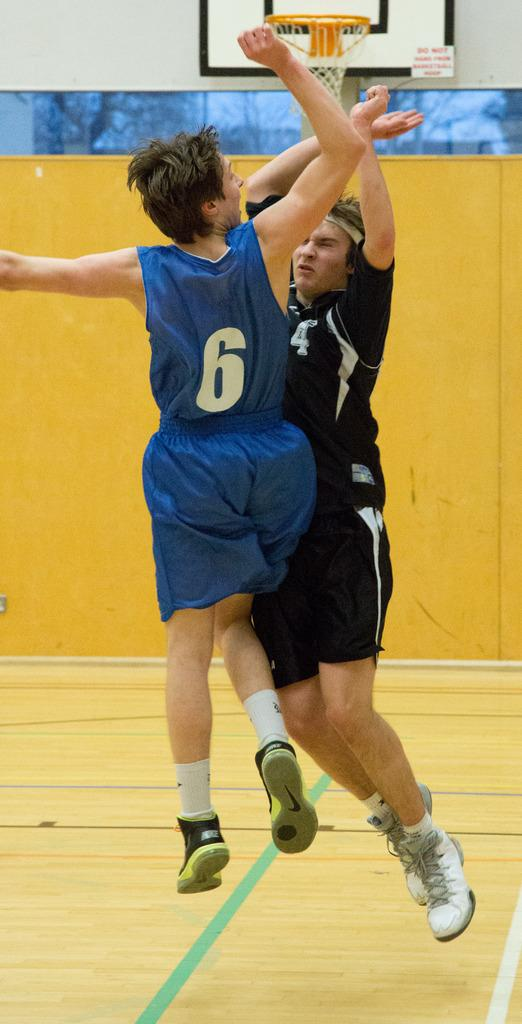Who are the main subjects in the image? There are two men in the center of the image. What are the men doing in the image? The men are jumping. What can be seen in the background of the image? There is a wall, a volleyball court, and boards in the background of the image. What is the surface on which the men are jumping? There is a floor at the bottom of the image. What type of map can be seen in the image? There is no map present in the image. What do the men need to complete their jump in the image? The men do not require any additional items or actions to complete their jump in the image. 